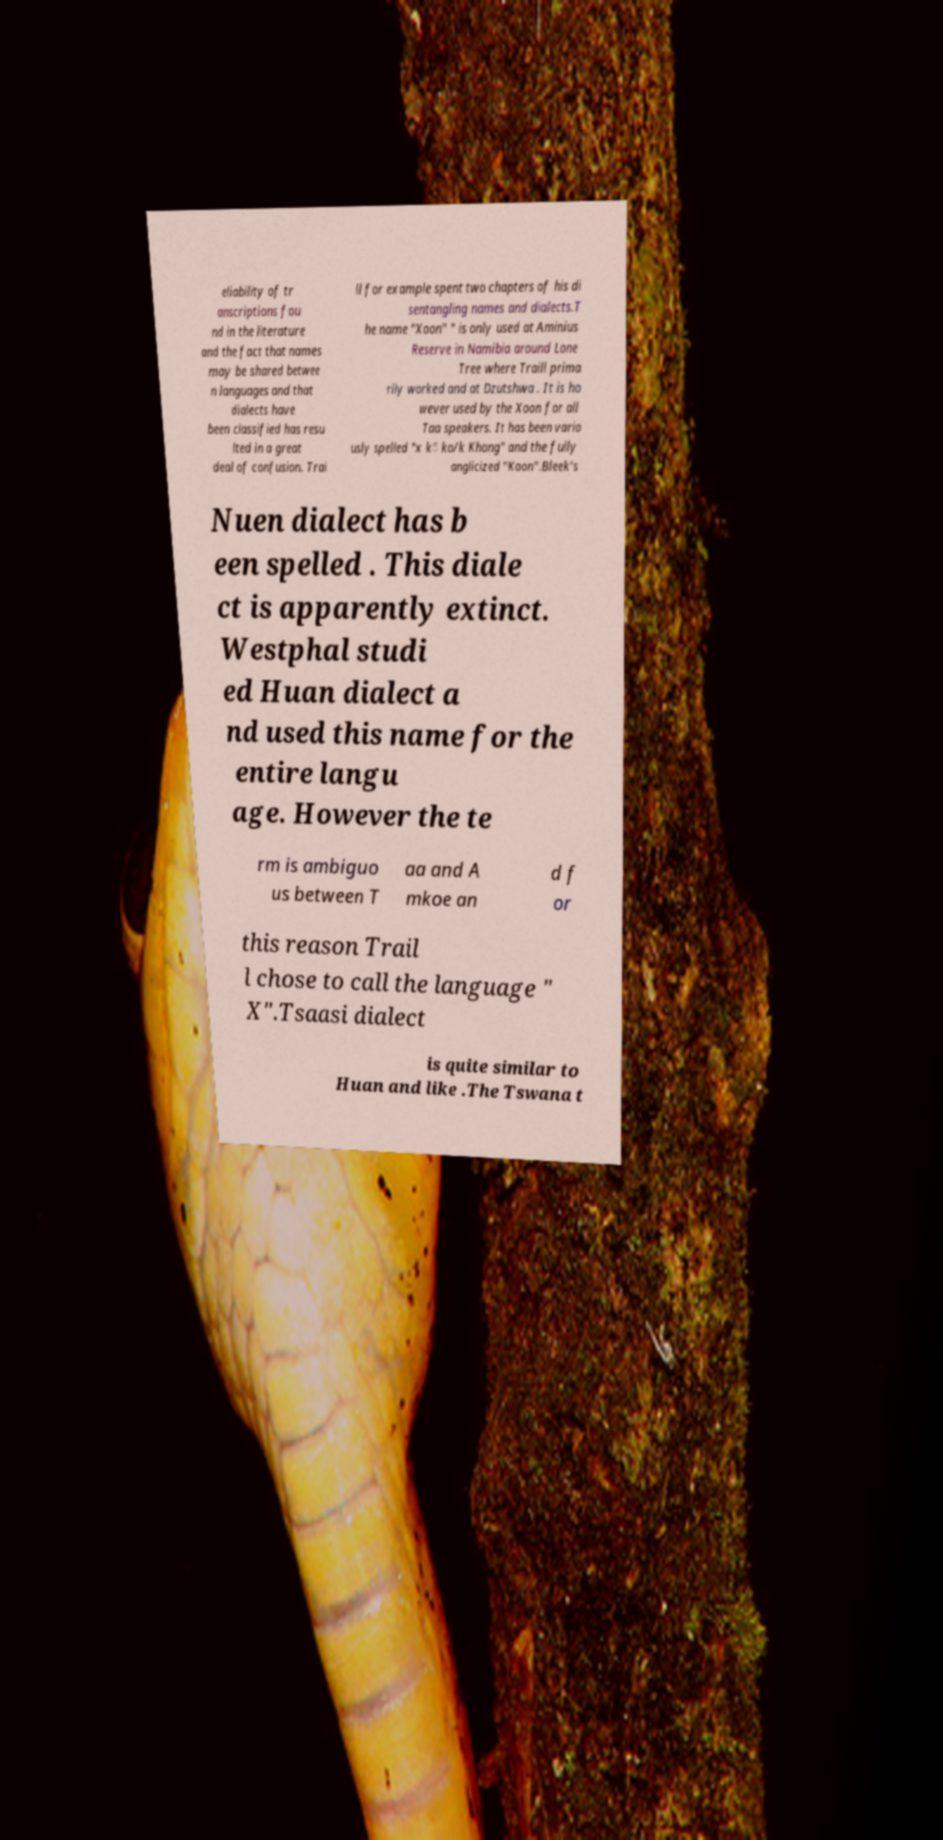Can you read and provide the text displayed in the image?This photo seems to have some interesting text. Can you extract and type it out for me? eliability of tr anscriptions fou nd in the literature and the fact that names may be shared betwee n languages and that dialects have been classified has resu lted in a great deal of confusion. Trai ll for example spent two chapters of his di sentangling names and dialects.T he name "Xoon" " is only used at Aminius Reserve in Namibia around Lone Tree where Traill prima rily worked and at Dzutshwa . It is ho wever used by the Xoon for all Taa speakers. It has been vario usly spelled "x k̃ ko/k Khong" and the fully anglicized "Koon".Bleek's Nuen dialect has b een spelled . This diale ct is apparently extinct. Westphal studi ed Huan dialect a nd used this name for the entire langu age. However the te rm is ambiguo us between T aa and A mkoe an d f or this reason Trail l chose to call the language " X".Tsaasi dialect is quite similar to Huan and like .The Tswana t 